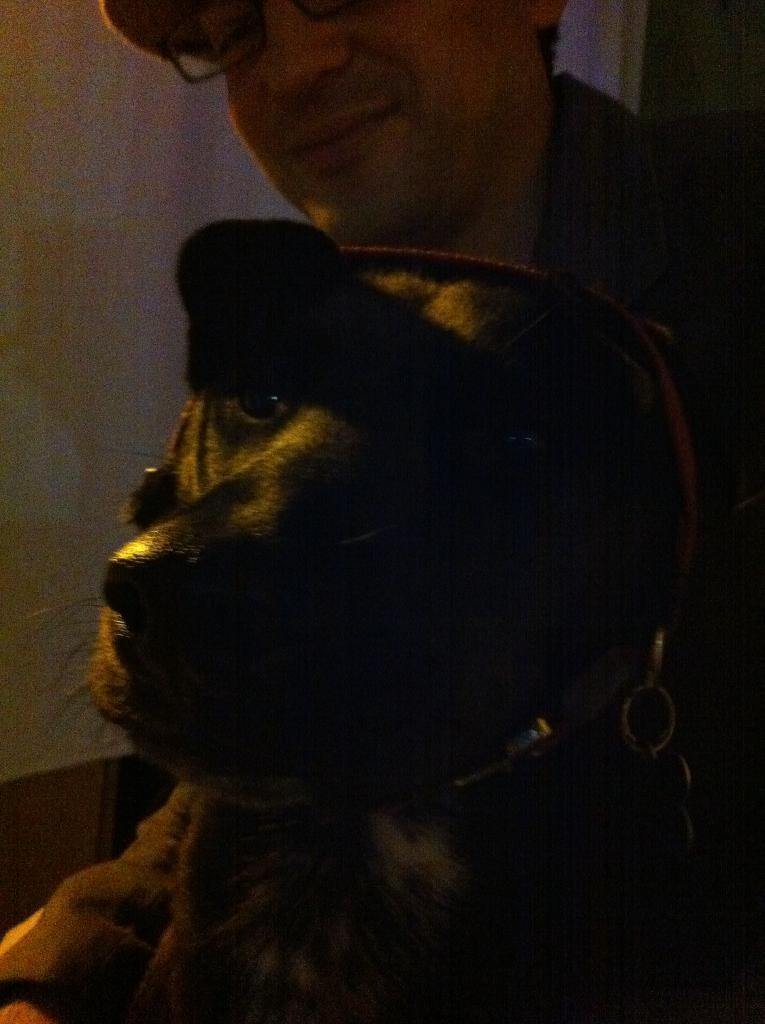How would you summarize this image in a sentence or two? In this image we can see a dog and a person. In the background of the image there is a wall and other objects. 